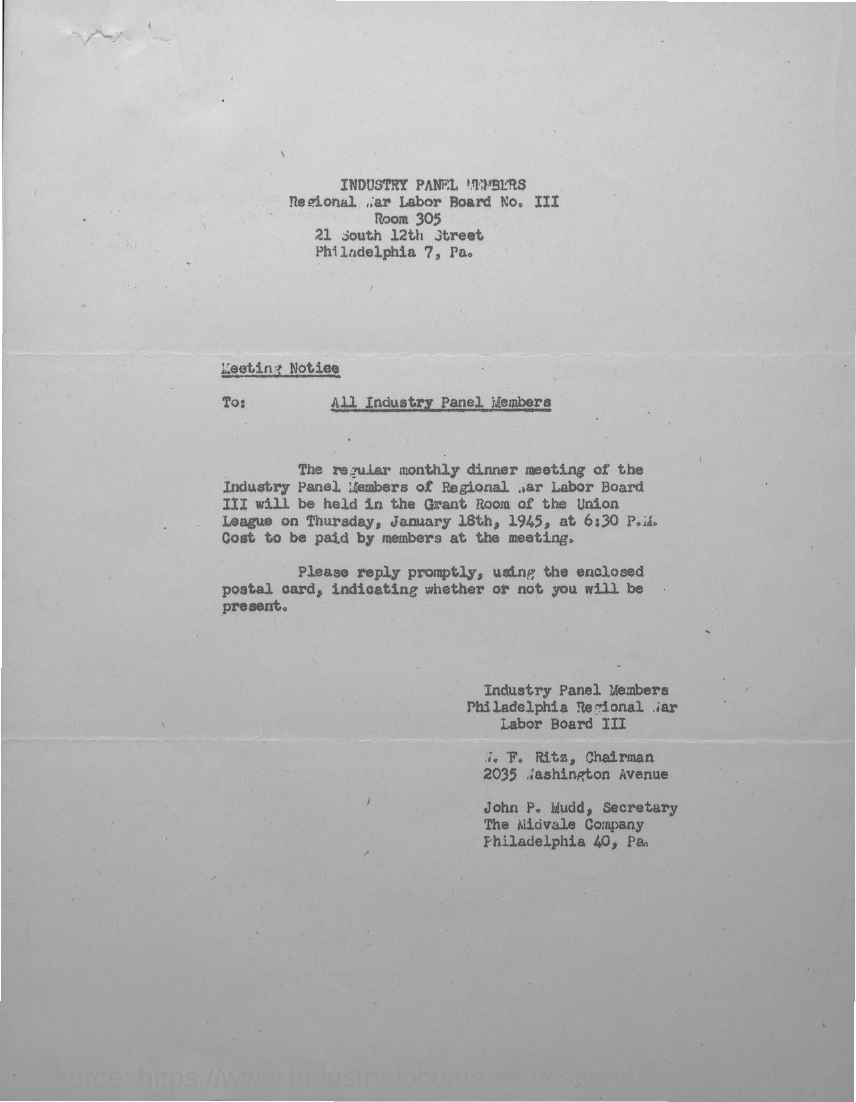To whom all, the meeting notice is addressed?
Your answer should be compact. All Industry Panel Members. 